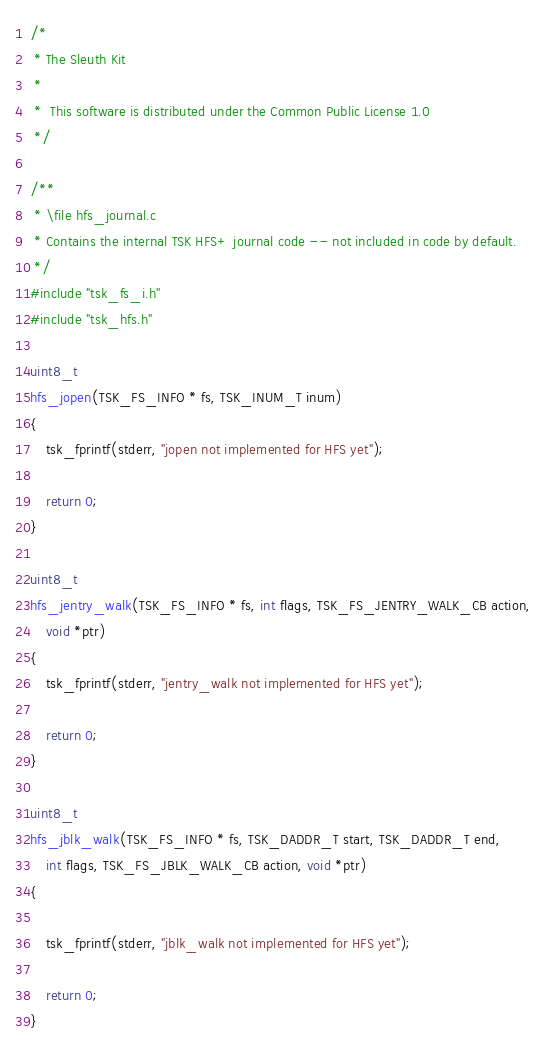<code> <loc_0><loc_0><loc_500><loc_500><_C_>/*
 * The Sleuth Kit
 * 
 *  This software is distributed under the Common Public License 1.0
 */

/**
 * \file hfs_journal.c
 * Contains the internal TSK HFS+ journal code -- not included in code by default.
 */
#include "tsk_fs_i.h"
#include "tsk_hfs.h"

uint8_t
hfs_jopen(TSK_FS_INFO * fs, TSK_INUM_T inum)
{
    tsk_fprintf(stderr, "jopen not implemented for HFS yet");

    return 0;
}

uint8_t
hfs_jentry_walk(TSK_FS_INFO * fs, int flags, TSK_FS_JENTRY_WALK_CB action,
    void *ptr)
{
    tsk_fprintf(stderr, "jentry_walk not implemented for HFS yet");

    return 0;
}

uint8_t
hfs_jblk_walk(TSK_FS_INFO * fs, TSK_DADDR_T start, TSK_DADDR_T end,
    int flags, TSK_FS_JBLK_WALK_CB action, void *ptr)
{

    tsk_fprintf(stderr, "jblk_walk not implemented for HFS yet");

    return 0;
}
</code> 